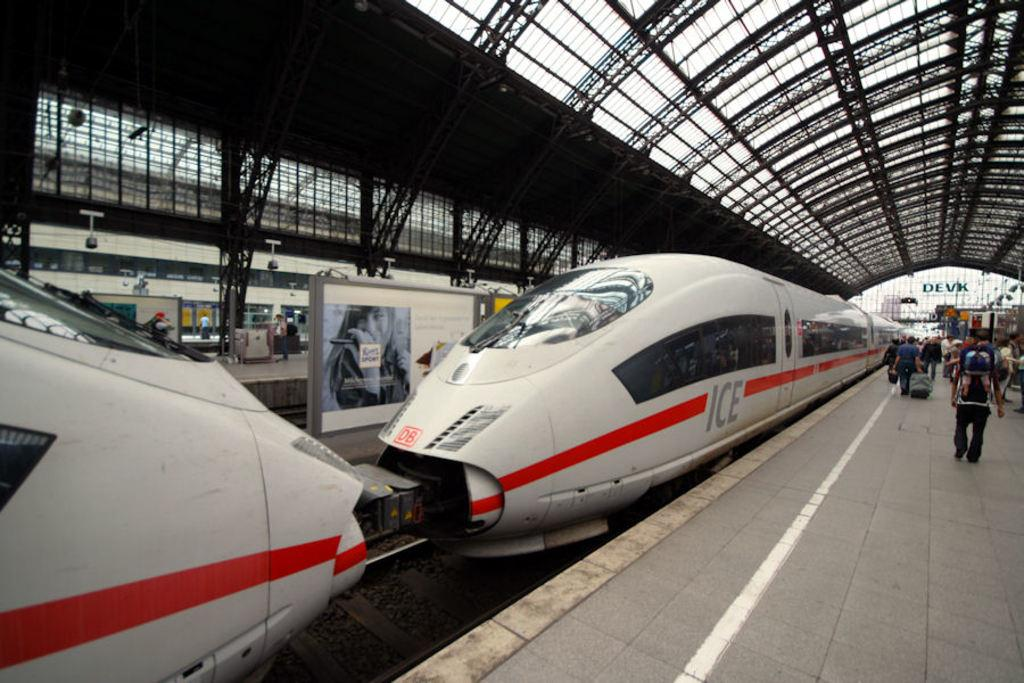<image>
Relay a brief, clear account of the picture shown. the ICE train is pulled into the station for loading 